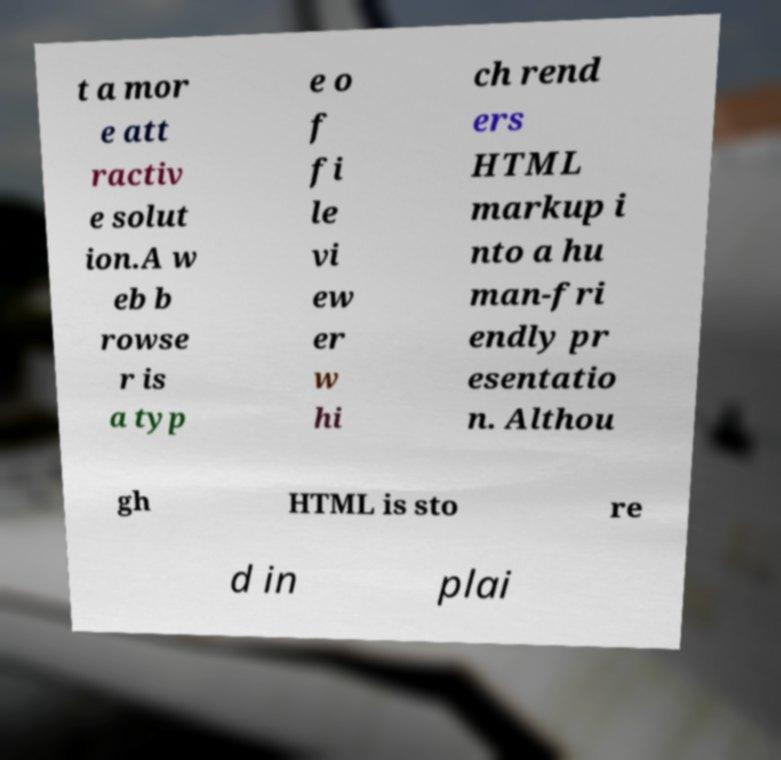What messages or text are displayed in this image? I need them in a readable, typed format. t a mor e att ractiv e solut ion.A w eb b rowse r is a typ e o f fi le vi ew er w hi ch rend ers HTML markup i nto a hu man-fri endly pr esentatio n. Althou gh HTML is sto re d in plai 